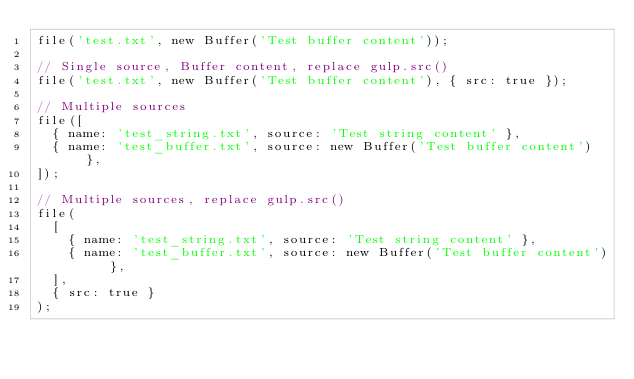Convert code to text. <code><loc_0><loc_0><loc_500><loc_500><_TypeScript_>file('test.txt', new Buffer('Test buffer content'));

// Single source, Buffer content, replace gulp.src()
file('test.txt', new Buffer('Test buffer content'), { src: true });

// Multiple sources
file([
  { name: 'test_string.txt', source: 'Test string content' },
  { name: 'test_buffer.txt', source: new Buffer('Test buffer content') },
]);

// Multiple sources, replace gulp.src()
file(
  [
    { name: 'test_string.txt', source: 'Test string content' },
    { name: 'test_buffer.txt', source: new Buffer('Test buffer content') },
  ],
  { src: true }
);
</code> 